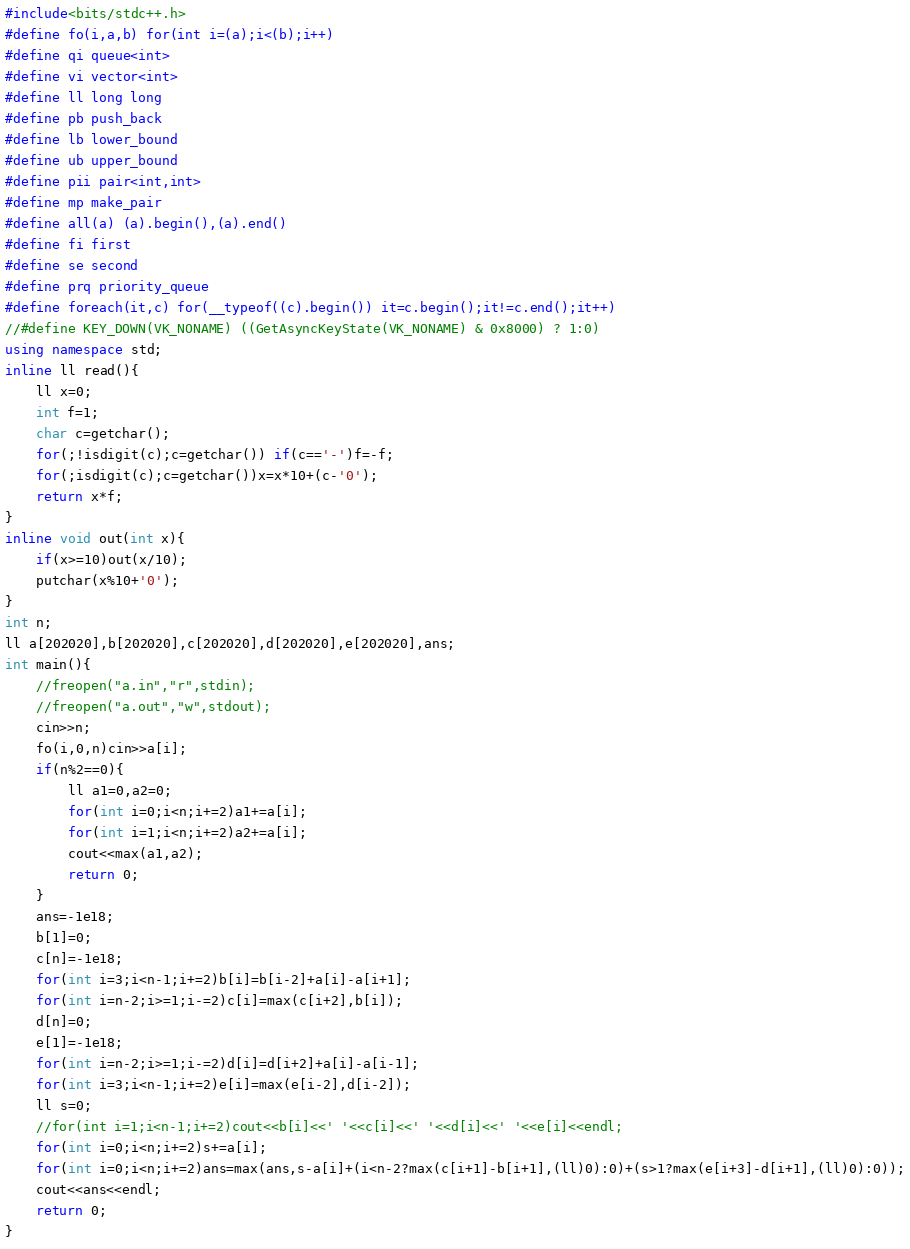Convert code to text. <code><loc_0><loc_0><loc_500><loc_500><_C++_>#include<bits/stdc++.h>
#define fo(i,a,b) for(int i=(a);i<(b);i++)
#define qi queue<int>
#define vi vector<int>
#define ll long long
#define pb push_back
#define lb lower_bound
#define ub upper_bound
#define pii pair<int,int>
#define mp make_pair
#define all(a) (a).begin(),(a).end()
#define fi first
#define se second 
#define prq priority_queue
#define foreach(it,c) for(__typeof((c).begin()) it=c.begin();it!=c.end();it++)
//#define KEY_DOWN(VK_NONAME) ((GetAsyncKeyState(VK_NONAME) & 0x8000) ? 1:0)
using namespace std;
inline ll read(){
	ll x=0;
	int f=1;
	char c=getchar();
	for(;!isdigit(c);c=getchar()) if(c=='-')f=-f;
	for(;isdigit(c);c=getchar())x=x*10+(c-'0');
	return x*f;
}
inline void out(int x){
	if(x>=10)out(x/10);
	putchar(x%10+'0');
}
int n;
ll a[202020],b[202020],c[202020],d[202020],e[202020],ans;
int main(){
	//freopen("a.in","r",stdin);
	//freopen("a.out","w",stdout);
	cin>>n;
	fo(i,0,n)cin>>a[i];
	if(n%2==0){
		ll a1=0,a2=0;
		for(int i=0;i<n;i+=2)a1+=a[i];	
		for(int i=1;i<n;i+=2)a2+=a[i];	
		cout<<max(a1,a2);
		return 0;
	}
	ans=-1e18; 
	b[1]=0;
	c[n]=-1e18;
	for(int i=3;i<n-1;i+=2)b[i]=b[i-2]+a[i]-a[i+1];
	for(int i=n-2;i>=1;i-=2)c[i]=max(c[i+2],b[i]);
	d[n]=0;
	e[1]=-1e18;
	for(int i=n-2;i>=1;i-=2)d[i]=d[i+2]+a[i]-a[i-1];
	for(int i=3;i<n-1;i+=2)e[i]=max(e[i-2],d[i-2]);
	ll s=0;
	//for(int i=1;i<n-1;i+=2)cout<<b[i]<<' '<<c[i]<<' '<<d[i]<<' '<<e[i]<<endl;
	for(int i=0;i<n;i+=2)s+=a[i];
	for(int i=0;i<n;i+=2)ans=max(ans,s-a[i]+(i<n-2?max(c[i+1]-b[i+1],(ll)0):0)+(s>1?max(e[i+3]-d[i+1],(ll)0):0));
	cout<<ans<<endl;
	return 0;
}</code> 